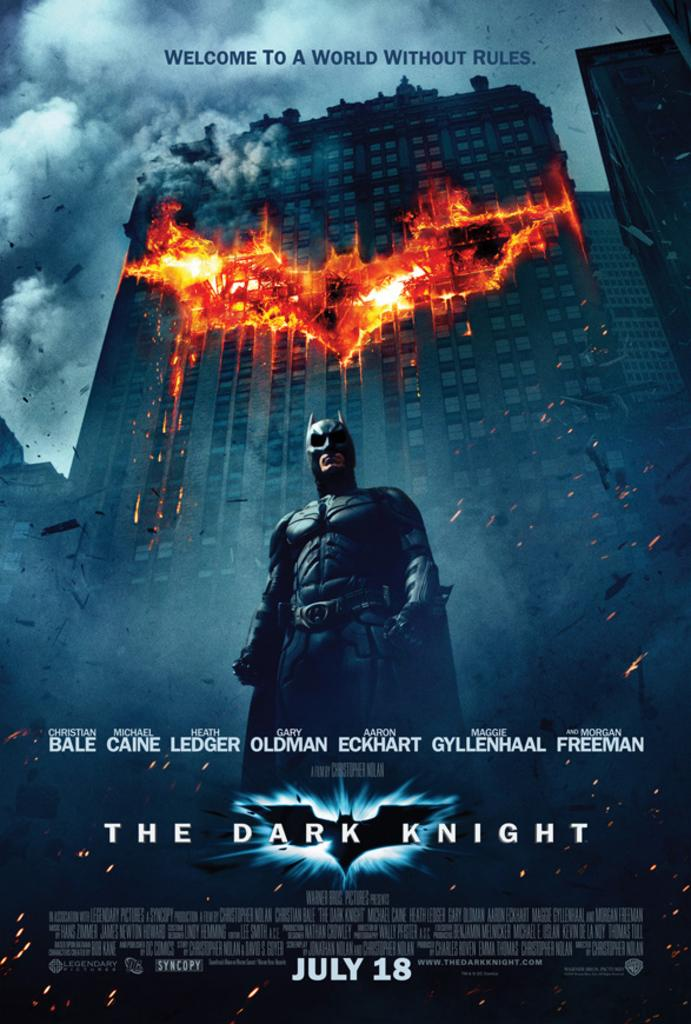Provide a one-sentence caption for the provided image. a poster for the movie The Dark Knight about Batman. 